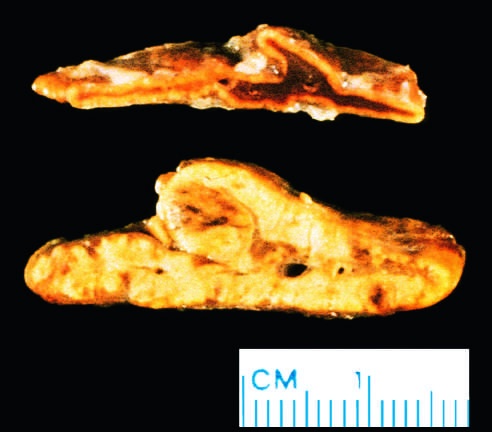what were diffusely hyperplastic?
Answer the question using a single word or phrase. Adrenal glands in a patient with acth-dependent cushing syndrome 